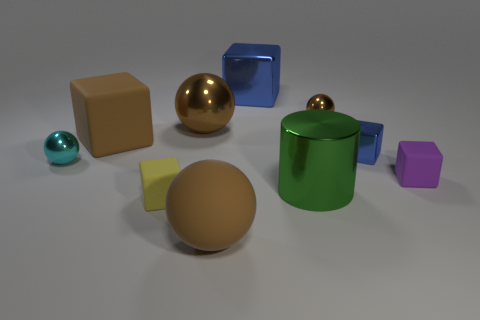How many brown balls must be subtracted to get 1 brown balls? 2 Subtract all big brown metal spheres. How many spheres are left? 3 Subtract all spheres. How many objects are left? 6 Subtract all brown blocks. How many blocks are left? 4 Subtract all purple spheres. How many blue cubes are left? 2 Subtract all blue spheres. Subtract all gray cylinders. How many spheres are left? 4 Subtract all yellow matte objects. Subtract all cyan cubes. How many objects are left? 9 Add 1 tiny cyan balls. How many tiny cyan balls are left? 2 Add 7 big blue things. How many big blue things exist? 8 Subtract 0 blue cylinders. How many objects are left? 10 